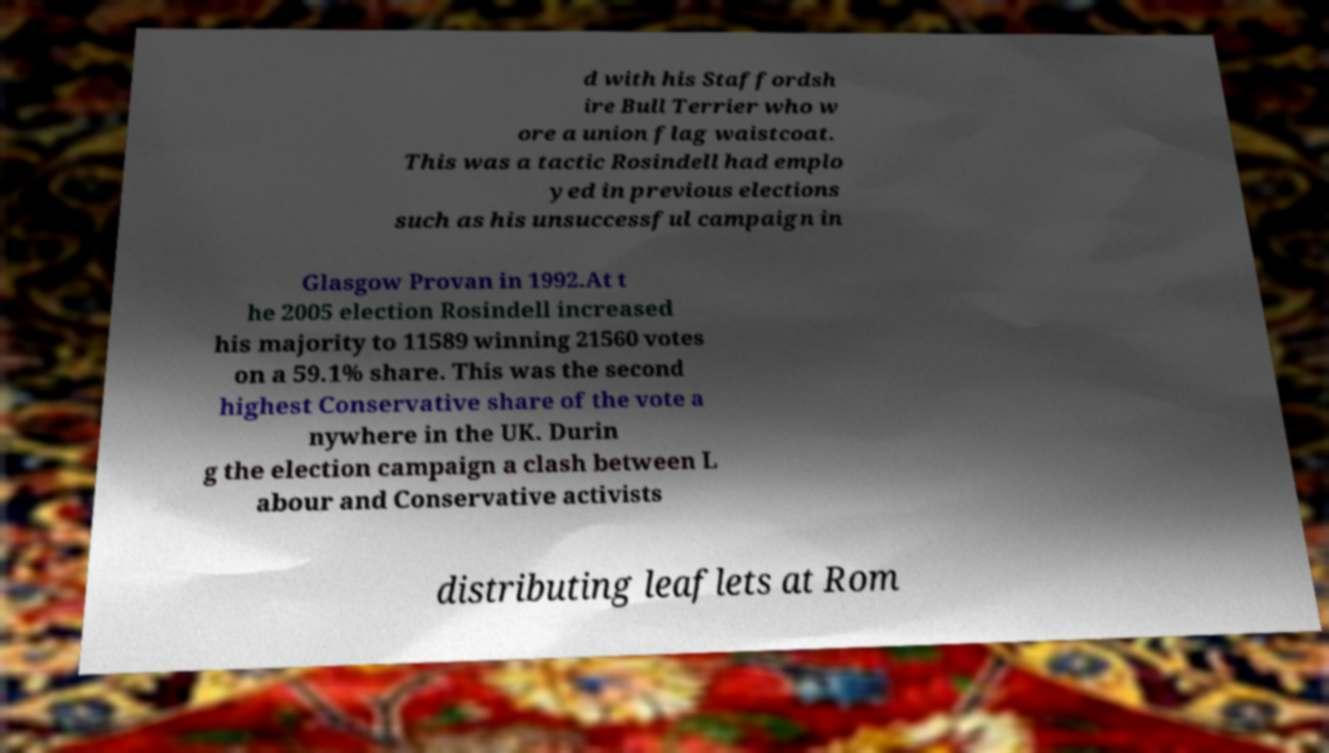Can you read and provide the text displayed in the image?This photo seems to have some interesting text. Can you extract and type it out for me? d with his Staffordsh ire Bull Terrier who w ore a union flag waistcoat. This was a tactic Rosindell had emplo yed in previous elections such as his unsuccessful campaign in Glasgow Provan in 1992.At t he 2005 election Rosindell increased his majority to 11589 winning 21560 votes on a 59.1% share. This was the second highest Conservative share of the vote a nywhere in the UK. Durin g the election campaign a clash between L abour and Conservative activists distributing leaflets at Rom 